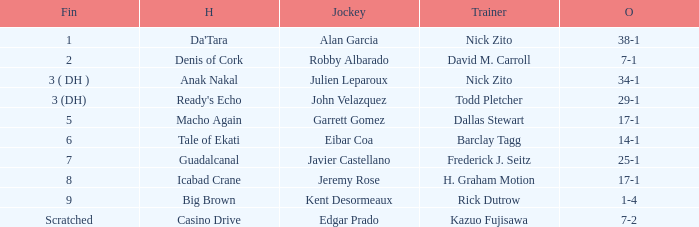What are the Odds for Trainer Barclay Tagg? 14-1. 